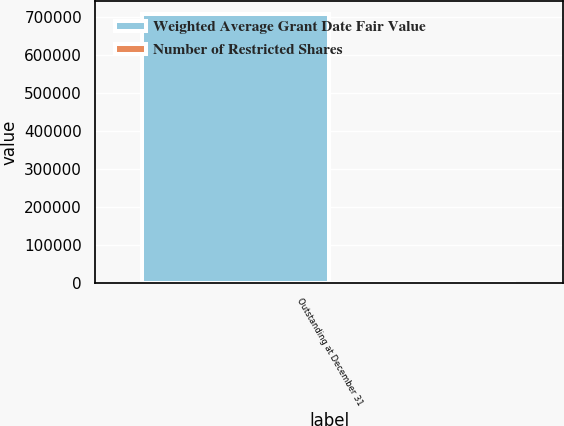Convert chart to OTSL. <chart><loc_0><loc_0><loc_500><loc_500><stacked_bar_chart><ecel><fcel>Outstanding at December 31<nl><fcel>Weighted Average Grant Date Fair Value<fcel>707003<nl><fcel>Number of Restricted Shares<fcel>12.69<nl></chart> 